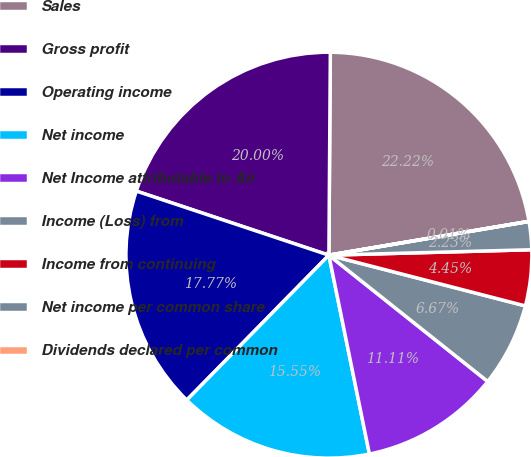<chart> <loc_0><loc_0><loc_500><loc_500><pie_chart><fcel>Sales<fcel>Gross profit<fcel>Operating income<fcel>Net income<fcel>Net Income attributable to Air<fcel>Income (Loss) from<fcel>Income from continuing<fcel>Net income per common share<fcel>Dividends declared per common<nl><fcel>22.22%<fcel>20.0%<fcel>17.77%<fcel>15.55%<fcel>11.11%<fcel>6.67%<fcel>4.45%<fcel>2.23%<fcel>0.01%<nl></chart> 